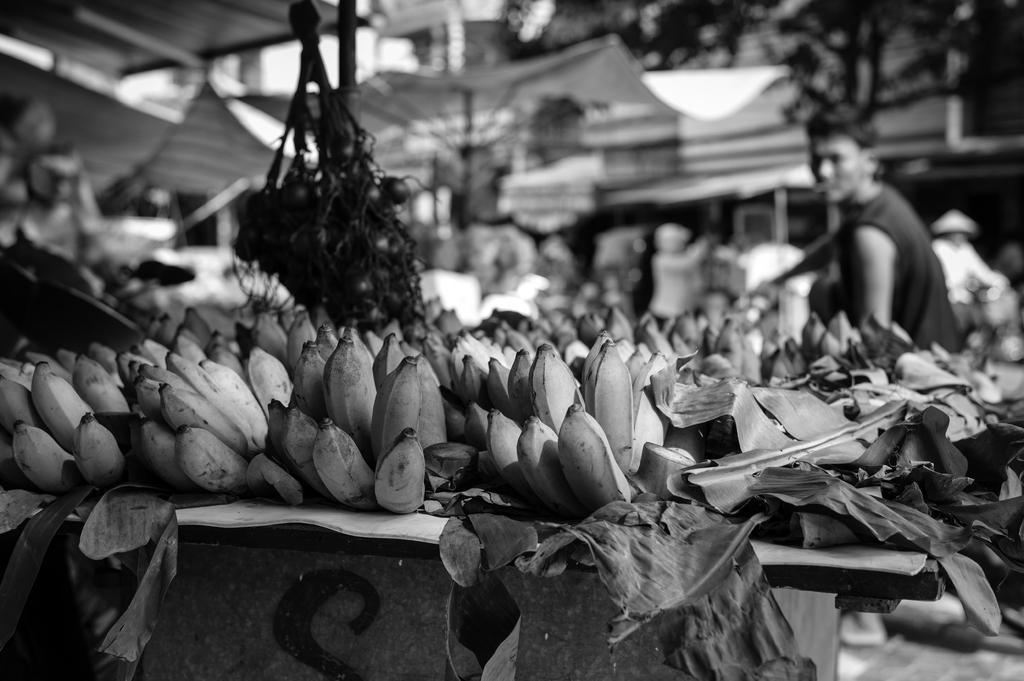How would you summarize this image in a sentence or two? In the image in the center, we can see one table. on the table, we can see leaves and bananas. In the background, we can see buildings, tents, banners, trees and few people. 